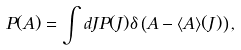<formula> <loc_0><loc_0><loc_500><loc_500>P ( A ) = \int d J P ( J ) \delta \left ( A - \langle A \rangle ( J ) \right ) ,</formula> 